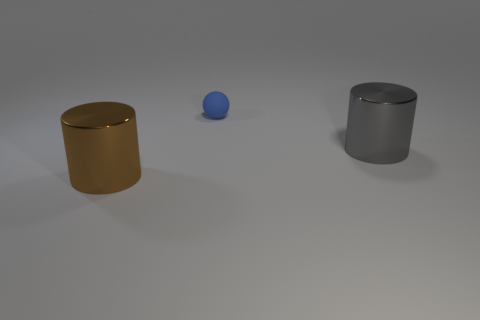Add 1 small spheres. How many objects exist? 4 Subtract all spheres. How many objects are left? 2 Subtract 0 yellow spheres. How many objects are left? 3 Subtract all large gray metal cylinders. Subtract all brown metallic cylinders. How many objects are left? 1 Add 1 small balls. How many small balls are left? 2 Add 2 big green rubber cubes. How many big green rubber cubes exist? 2 